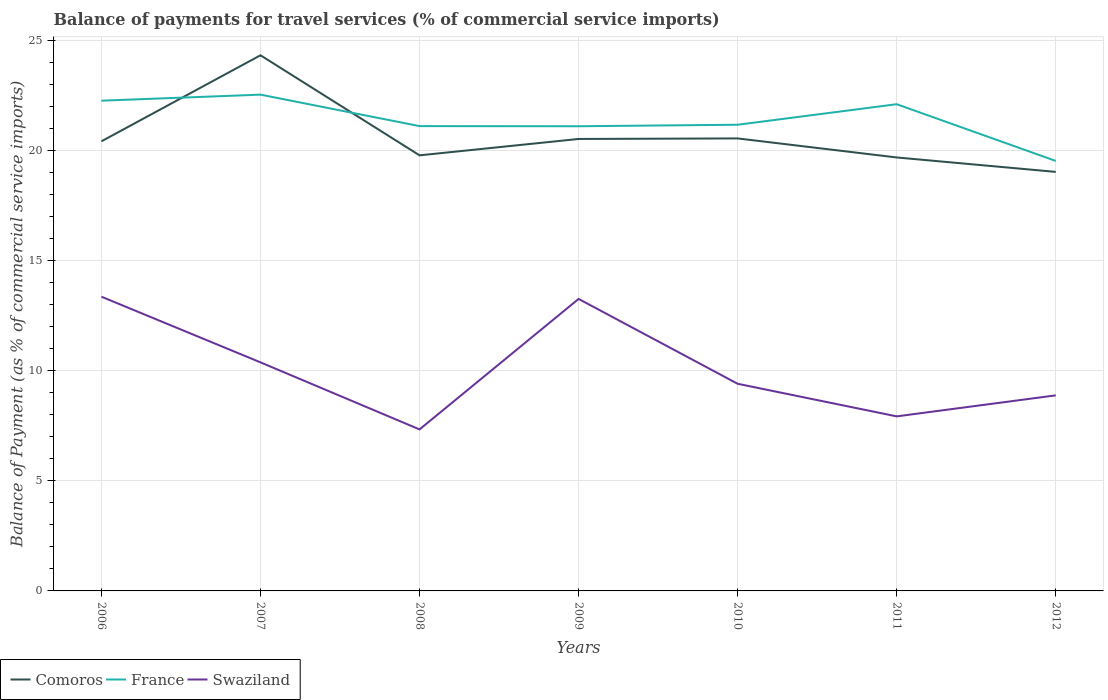Is the number of lines equal to the number of legend labels?
Keep it short and to the point. Yes. Across all years, what is the maximum balance of payments for travel services in Comoros?
Make the answer very short. 19.03. What is the total balance of payments for travel services in France in the graph?
Provide a short and direct response. 1.15. What is the difference between the highest and the second highest balance of payments for travel services in Comoros?
Provide a succinct answer. 5.3. How many lines are there?
Provide a succinct answer. 3. Are the values on the major ticks of Y-axis written in scientific E-notation?
Your answer should be compact. No. Does the graph contain any zero values?
Offer a very short reply. No. Does the graph contain grids?
Your answer should be compact. Yes. How are the legend labels stacked?
Your answer should be very brief. Horizontal. What is the title of the graph?
Your answer should be very brief. Balance of payments for travel services (% of commercial service imports). What is the label or title of the Y-axis?
Your answer should be compact. Balance of Payment (as % of commercial service imports). What is the Balance of Payment (as % of commercial service imports) in Comoros in 2006?
Provide a succinct answer. 20.42. What is the Balance of Payment (as % of commercial service imports) in France in 2006?
Ensure brevity in your answer.  22.26. What is the Balance of Payment (as % of commercial service imports) in Swaziland in 2006?
Offer a very short reply. 13.36. What is the Balance of Payment (as % of commercial service imports) of Comoros in 2007?
Offer a very short reply. 24.32. What is the Balance of Payment (as % of commercial service imports) in France in 2007?
Provide a short and direct response. 22.54. What is the Balance of Payment (as % of commercial service imports) of Swaziland in 2007?
Your answer should be compact. 10.38. What is the Balance of Payment (as % of commercial service imports) of Comoros in 2008?
Your response must be concise. 19.78. What is the Balance of Payment (as % of commercial service imports) in France in 2008?
Your answer should be very brief. 21.11. What is the Balance of Payment (as % of commercial service imports) in Swaziland in 2008?
Keep it short and to the point. 7.34. What is the Balance of Payment (as % of commercial service imports) in Comoros in 2009?
Your response must be concise. 20.52. What is the Balance of Payment (as % of commercial service imports) of France in 2009?
Ensure brevity in your answer.  21.1. What is the Balance of Payment (as % of commercial service imports) in Swaziland in 2009?
Your response must be concise. 13.26. What is the Balance of Payment (as % of commercial service imports) of Comoros in 2010?
Your response must be concise. 20.55. What is the Balance of Payment (as % of commercial service imports) of France in 2010?
Keep it short and to the point. 21.17. What is the Balance of Payment (as % of commercial service imports) of Swaziland in 2010?
Provide a succinct answer. 9.41. What is the Balance of Payment (as % of commercial service imports) of Comoros in 2011?
Give a very brief answer. 19.68. What is the Balance of Payment (as % of commercial service imports) in France in 2011?
Give a very brief answer. 22.1. What is the Balance of Payment (as % of commercial service imports) in Swaziland in 2011?
Your answer should be very brief. 7.93. What is the Balance of Payment (as % of commercial service imports) of Comoros in 2012?
Provide a short and direct response. 19.03. What is the Balance of Payment (as % of commercial service imports) in France in 2012?
Ensure brevity in your answer.  19.53. What is the Balance of Payment (as % of commercial service imports) in Swaziland in 2012?
Offer a terse response. 8.88. Across all years, what is the maximum Balance of Payment (as % of commercial service imports) in Comoros?
Provide a short and direct response. 24.32. Across all years, what is the maximum Balance of Payment (as % of commercial service imports) in France?
Provide a short and direct response. 22.54. Across all years, what is the maximum Balance of Payment (as % of commercial service imports) in Swaziland?
Provide a short and direct response. 13.36. Across all years, what is the minimum Balance of Payment (as % of commercial service imports) of Comoros?
Offer a terse response. 19.03. Across all years, what is the minimum Balance of Payment (as % of commercial service imports) in France?
Your answer should be very brief. 19.53. Across all years, what is the minimum Balance of Payment (as % of commercial service imports) in Swaziland?
Your response must be concise. 7.34. What is the total Balance of Payment (as % of commercial service imports) of Comoros in the graph?
Offer a terse response. 144.31. What is the total Balance of Payment (as % of commercial service imports) of France in the graph?
Make the answer very short. 149.81. What is the total Balance of Payment (as % of commercial service imports) in Swaziland in the graph?
Ensure brevity in your answer.  70.55. What is the difference between the Balance of Payment (as % of commercial service imports) in Comoros in 2006 and that in 2007?
Give a very brief answer. -3.91. What is the difference between the Balance of Payment (as % of commercial service imports) of France in 2006 and that in 2007?
Offer a very short reply. -0.27. What is the difference between the Balance of Payment (as % of commercial service imports) in Swaziland in 2006 and that in 2007?
Give a very brief answer. 2.98. What is the difference between the Balance of Payment (as % of commercial service imports) in Comoros in 2006 and that in 2008?
Keep it short and to the point. 0.64. What is the difference between the Balance of Payment (as % of commercial service imports) of France in 2006 and that in 2008?
Give a very brief answer. 1.15. What is the difference between the Balance of Payment (as % of commercial service imports) in Swaziland in 2006 and that in 2008?
Provide a succinct answer. 6.03. What is the difference between the Balance of Payment (as % of commercial service imports) of Comoros in 2006 and that in 2009?
Your response must be concise. -0.11. What is the difference between the Balance of Payment (as % of commercial service imports) of France in 2006 and that in 2009?
Offer a terse response. 1.16. What is the difference between the Balance of Payment (as % of commercial service imports) of Swaziland in 2006 and that in 2009?
Offer a very short reply. 0.1. What is the difference between the Balance of Payment (as % of commercial service imports) of Comoros in 2006 and that in 2010?
Your answer should be very brief. -0.13. What is the difference between the Balance of Payment (as % of commercial service imports) in France in 2006 and that in 2010?
Ensure brevity in your answer.  1.09. What is the difference between the Balance of Payment (as % of commercial service imports) in Swaziland in 2006 and that in 2010?
Provide a short and direct response. 3.95. What is the difference between the Balance of Payment (as % of commercial service imports) of Comoros in 2006 and that in 2011?
Your answer should be compact. 0.73. What is the difference between the Balance of Payment (as % of commercial service imports) of France in 2006 and that in 2011?
Your answer should be compact. 0.16. What is the difference between the Balance of Payment (as % of commercial service imports) in Swaziland in 2006 and that in 2011?
Keep it short and to the point. 5.43. What is the difference between the Balance of Payment (as % of commercial service imports) in Comoros in 2006 and that in 2012?
Make the answer very short. 1.39. What is the difference between the Balance of Payment (as % of commercial service imports) of France in 2006 and that in 2012?
Your answer should be compact. 2.74. What is the difference between the Balance of Payment (as % of commercial service imports) of Swaziland in 2006 and that in 2012?
Your answer should be very brief. 4.48. What is the difference between the Balance of Payment (as % of commercial service imports) in Comoros in 2007 and that in 2008?
Ensure brevity in your answer.  4.54. What is the difference between the Balance of Payment (as % of commercial service imports) in France in 2007 and that in 2008?
Your answer should be very brief. 1.43. What is the difference between the Balance of Payment (as % of commercial service imports) in Swaziland in 2007 and that in 2008?
Offer a very short reply. 3.04. What is the difference between the Balance of Payment (as % of commercial service imports) in Comoros in 2007 and that in 2009?
Your response must be concise. 3.8. What is the difference between the Balance of Payment (as % of commercial service imports) in France in 2007 and that in 2009?
Offer a very short reply. 1.44. What is the difference between the Balance of Payment (as % of commercial service imports) of Swaziland in 2007 and that in 2009?
Your answer should be compact. -2.88. What is the difference between the Balance of Payment (as % of commercial service imports) of Comoros in 2007 and that in 2010?
Give a very brief answer. 3.78. What is the difference between the Balance of Payment (as % of commercial service imports) of France in 2007 and that in 2010?
Offer a very short reply. 1.37. What is the difference between the Balance of Payment (as % of commercial service imports) of Swaziland in 2007 and that in 2010?
Offer a terse response. 0.97. What is the difference between the Balance of Payment (as % of commercial service imports) of Comoros in 2007 and that in 2011?
Make the answer very short. 4.64. What is the difference between the Balance of Payment (as % of commercial service imports) of France in 2007 and that in 2011?
Keep it short and to the point. 0.43. What is the difference between the Balance of Payment (as % of commercial service imports) of Swaziland in 2007 and that in 2011?
Offer a terse response. 2.45. What is the difference between the Balance of Payment (as % of commercial service imports) of Comoros in 2007 and that in 2012?
Your answer should be compact. 5.3. What is the difference between the Balance of Payment (as % of commercial service imports) in France in 2007 and that in 2012?
Make the answer very short. 3.01. What is the difference between the Balance of Payment (as % of commercial service imports) in Swaziland in 2007 and that in 2012?
Ensure brevity in your answer.  1.5. What is the difference between the Balance of Payment (as % of commercial service imports) in Comoros in 2008 and that in 2009?
Make the answer very short. -0.74. What is the difference between the Balance of Payment (as % of commercial service imports) of France in 2008 and that in 2009?
Provide a short and direct response. 0.01. What is the difference between the Balance of Payment (as % of commercial service imports) in Swaziland in 2008 and that in 2009?
Keep it short and to the point. -5.92. What is the difference between the Balance of Payment (as % of commercial service imports) in Comoros in 2008 and that in 2010?
Your response must be concise. -0.77. What is the difference between the Balance of Payment (as % of commercial service imports) in France in 2008 and that in 2010?
Give a very brief answer. -0.06. What is the difference between the Balance of Payment (as % of commercial service imports) in Swaziland in 2008 and that in 2010?
Your response must be concise. -2.07. What is the difference between the Balance of Payment (as % of commercial service imports) of Comoros in 2008 and that in 2011?
Keep it short and to the point. 0.1. What is the difference between the Balance of Payment (as % of commercial service imports) in France in 2008 and that in 2011?
Offer a very short reply. -0.99. What is the difference between the Balance of Payment (as % of commercial service imports) in Swaziland in 2008 and that in 2011?
Ensure brevity in your answer.  -0.59. What is the difference between the Balance of Payment (as % of commercial service imports) of Comoros in 2008 and that in 2012?
Your answer should be compact. 0.75. What is the difference between the Balance of Payment (as % of commercial service imports) of France in 2008 and that in 2012?
Ensure brevity in your answer.  1.58. What is the difference between the Balance of Payment (as % of commercial service imports) in Swaziland in 2008 and that in 2012?
Keep it short and to the point. -1.55. What is the difference between the Balance of Payment (as % of commercial service imports) in Comoros in 2009 and that in 2010?
Keep it short and to the point. -0.02. What is the difference between the Balance of Payment (as % of commercial service imports) of France in 2009 and that in 2010?
Provide a short and direct response. -0.07. What is the difference between the Balance of Payment (as % of commercial service imports) of Swaziland in 2009 and that in 2010?
Offer a terse response. 3.85. What is the difference between the Balance of Payment (as % of commercial service imports) in Comoros in 2009 and that in 2011?
Your answer should be compact. 0.84. What is the difference between the Balance of Payment (as % of commercial service imports) in France in 2009 and that in 2011?
Ensure brevity in your answer.  -1. What is the difference between the Balance of Payment (as % of commercial service imports) of Swaziland in 2009 and that in 2011?
Your answer should be compact. 5.33. What is the difference between the Balance of Payment (as % of commercial service imports) in Comoros in 2009 and that in 2012?
Provide a short and direct response. 1.5. What is the difference between the Balance of Payment (as % of commercial service imports) in France in 2009 and that in 2012?
Provide a short and direct response. 1.58. What is the difference between the Balance of Payment (as % of commercial service imports) in Swaziland in 2009 and that in 2012?
Provide a short and direct response. 4.38. What is the difference between the Balance of Payment (as % of commercial service imports) in Comoros in 2010 and that in 2011?
Keep it short and to the point. 0.86. What is the difference between the Balance of Payment (as % of commercial service imports) of France in 2010 and that in 2011?
Keep it short and to the point. -0.93. What is the difference between the Balance of Payment (as % of commercial service imports) of Swaziland in 2010 and that in 2011?
Give a very brief answer. 1.48. What is the difference between the Balance of Payment (as % of commercial service imports) of Comoros in 2010 and that in 2012?
Your response must be concise. 1.52. What is the difference between the Balance of Payment (as % of commercial service imports) in France in 2010 and that in 2012?
Your answer should be compact. 1.64. What is the difference between the Balance of Payment (as % of commercial service imports) of Swaziland in 2010 and that in 2012?
Offer a terse response. 0.53. What is the difference between the Balance of Payment (as % of commercial service imports) in Comoros in 2011 and that in 2012?
Your response must be concise. 0.66. What is the difference between the Balance of Payment (as % of commercial service imports) of France in 2011 and that in 2012?
Your answer should be compact. 2.58. What is the difference between the Balance of Payment (as % of commercial service imports) in Swaziland in 2011 and that in 2012?
Your answer should be very brief. -0.95. What is the difference between the Balance of Payment (as % of commercial service imports) in Comoros in 2006 and the Balance of Payment (as % of commercial service imports) in France in 2007?
Keep it short and to the point. -2.12. What is the difference between the Balance of Payment (as % of commercial service imports) in Comoros in 2006 and the Balance of Payment (as % of commercial service imports) in Swaziland in 2007?
Keep it short and to the point. 10.04. What is the difference between the Balance of Payment (as % of commercial service imports) in France in 2006 and the Balance of Payment (as % of commercial service imports) in Swaziland in 2007?
Your answer should be compact. 11.88. What is the difference between the Balance of Payment (as % of commercial service imports) of Comoros in 2006 and the Balance of Payment (as % of commercial service imports) of France in 2008?
Keep it short and to the point. -0.69. What is the difference between the Balance of Payment (as % of commercial service imports) in Comoros in 2006 and the Balance of Payment (as % of commercial service imports) in Swaziland in 2008?
Provide a short and direct response. 13.08. What is the difference between the Balance of Payment (as % of commercial service imports) of France in 2006 and the Balance of Payment (as % of commercial service imports) of Swaziland in 2008?
Offer a very short reply. 14.93. What is the difference between the Balance of Payment (as % of commercial service imports) of Comoros in 2006 and the Balance of Payment (as % of commercial service imports) of France in 2009?
Your answer should be compact. -0.68. What is the difference between the Balance of Payment (as % of commercial service imports) of Comoros in 2006 and the Balance of Payment (as % of commercial service imports) of Swaziland in 2009?
Your answer should be compact. 7.16. What is the difference between the Balance of Payment (as % of commercial service imports) of France in 2006 and the Balance of Payment (as % of commercial service imports) of Swaziland in 2009?
Make the answer very short. 9. What is the difference between the Balance of Payment (as % of commercial service imports) of Comoros in 2006 and the Balance of Payment (as % of commercial service imports) of France in 2010?
Your answer should be compact. -0.75. What is the difference between the Balance of Payment (as % of commercial service imports) in Comoros in 2006 and the Balance of Payment (as % of commercial service imports) in Swaziland in 2010?
Provide a short and direct response. 11.01. What is the difference between the Balance of Payment (as % of commercial service imports) in France in 2006 and the Balance of Payment (as % of commercial service imports) in Swaziland in 2010?
Your answer should be very brief. 12.86. What is the difference between the Balance of Payment (as % of commercial service imports) of Comoros in 2006 and the Balance of Payment (as % of commercial service imports) of France in 2011?
Make the answer very short. -1.68. What is the difference between the Balance of Payment (as % of commercial service imports) in Comoros in 2006 and the Balance of Payment (as % of commercial service imports) in Swaziland in 2011?
Make the answer very short. 12.49. What is the difference between the Balance of Payment (as % of commercial service imports) of France in 2006 and the Balance of Payment (as % of commercial service imports) of Swaziland in 2011?
Keep it short and to the point. 14.34. What is the difference between the Balance of Payment (as % of commercial service imports) in Comoros in 2006 and the Balance of Payment (as % of commercial service imports) in France in 2012?
Your answer should be compact. 0.89. What is the difference between the Balance of Payment (as % of commercial service imports) in Comoros in 2006 and the Balance of Payment (as % of commercial service imports) in Swaziland in 2012?
Your answer should be compact. 11.54. What is the difference between the Balance of Payment (as % of commercial service imports) in France in 2006 and the Balance of Payment (as % of commercial service imports) in Swaziland in 2012?
Make the answer very short. 13.38. What is the difference between the Balance of Payment (as % of commercial service imports) in Comoros in 2007 and the Balance of Payment (as % of commercial service imports) in France in 2008?
Ensure brevity in your answer.  3.22. What is the difference between the Balance of Payment (as % of commercial service imports) of Comoros in 2007 and the Balance of Payment (as % of commercial service imports) of Swaziland in 2008?
Your answer should be very brief. 16.99. What is the difference between the Balance of Payment (as % of commercial service imports) in France in 2007 and the Balance of Payment (as % of commercial service imports) in Swaziland in 2008?
Give a very brief answer. 15.2. What is the difference between the Balance of Payment (as % of commercial service imports) of Comoros in 2007 and the Balance of Payment (as % of commercial service imports) of France in 2009?
Provide a short and direct response. 3.22. What is the difference between the Balance of Payment (as % of commercial service imports) of Comoros in 2007 and the Balance of Payment (as % of commercial service imports) of Swaziland in 2009?
Ensure brevity in your answer.  11.06. What is the difference between the Balance of Payment (as % of commercial service imports) in France in 2007 and the Balance of Payment (as % of commercial service imports) in Swaziland in 2009?
Offer a terse response. 9.28. What is the difference between the Balance of Payment (as % of commercial service imports) of Comoros in 2007 and the Balance of Payment (as % of commercial service imports) of France in 2010?
Give a very brief answer. 3.15. What is the difference between the Balance of Payment (as % of commercial service imports) in Comoros in 2007 and the Balance of Payment (as % of commercial service imports) in Swaziland in 2010?
Offer a terse response. 14.92. What is the difference between the Balance of Payment (as % of commercial service imports) in France in 2007 and the Balance of Payment (as % of commercial service imports) in Swaziland in 2010?
Make the answer very short. 13.13. What is the difference between the Balance of Payment (as % of commercial service imports) in Comoros in 2007 and the Balance of Payment (as % of commercial service imports) in France in 2011?
Make the answer very short. 2.22. What is the difference between the Balance of Payment (as % of commercial service imports) in Comoros in 2007 and the Balance of Payment (as % of commercial service imports) in Swaziland in 2011?
Offer a very short reply. 16.4. What is the difference between the Balance of Payment (as % of commercial service imports) of France in 2007 and the Balance of Payment (as % of commercial service imports) of Swaziland in 2011?
Ensure brevity in your answer.  14.61. What is the difference between the Balance of Payment (as % of commercial service imports) in Comoros in 2007 and the Balance of Payment (as % of commercial service imports) in France in 2012?
Your answer should be compact. 4.8. What is the difference between the Balance of Payment (as % of commercial service imports) of Comoros in 2007 and the Balance of Payment (as % of commercial service imports) of Swaziland in 2012?
Offer a very short reply. 15.44. What is the difference between the Balance of Payment (as % of commercial service imports) of France in 2007 and the Balance of Payment (as % of commercial service imports) of Swaziland in 2012?
Ensure brevity in your answer.  13.66. What is the difference between the Balance of Payment (as % of commercial service imports) of Comoros in 2008 and the Balance of Payment (as % of commercial service imports) of France in 2009?
Your response must be concise. -1.32. What is the difference between the Balance of Payment (as % of commercial service imports) in Comoros in 2008 and the Balance of Payment (as % of commercial service imports) in Swaziland in 2009?
Ensure brevity in your answer.  6.52. What is the difference between the Balance of Payment (as % of commercial service imports) of France in 2008 and the Balance of Payment (as % of commercial service imports) of Swaziland in 2009?
Provide a succinct answer. 7.85. What is the difference between the Balance of Payment (as % of commercial service imports) in Comoros in 2008 and the Balance of Payment (as % of commercial service imports) in France in 2010?
Offer a very short reply. -1.39. What is the difference between the Balance of Payment (as % of commercial service imports) in Comoros in 2008 and the Balance of Payment (as % of commercial service imports) in Swaziland in 2010?
Give a very brief answer. 10.37. What is the difference between the Balance of Payment (as % of commercial service imports) of France in 2008 and the Balance of Payment (as % of commercial service imports) of Swaziland in 2010?
Give a very brief answer. 11.7. What is the difference between the Balance of Payment (as % of commercial service imports) of Comoros in 2008 and the Balance of Payment (as % of commercial service imports) of France in 2011?
Make the answer very short. -2.32. What is the difference between the Balance of Payment (as % of commercial service imports) of Comoros in 2008 and the Balance of Payment (as % of commercial service imports) of Swaziland in 2011?
Give a very brief answer. 11.85. What is the difference between the Balance of Payment (as % of commercial service imports) in France in 2008 and the Balance of Payment (as % of commercial service imports) in Swaziland in 2011?
Ensure brevity in your answer.  13.18. What is the difference between the Balance of Payment (as % of commercial service imports) of Comoros in 2008 and the Balance of Payment (as % of commercial service imports) of France in 2012?
Give a very brief answer. 0.25. What is the difference between the Balance of Payment (as % of commercial service imports) of Comoros in 2008 and the Balance of Payment (as % of commercial service imports) of Swaziland in 2012?
Provide a succinct answer. 10.9. What is the difference between the Balance of Payment (as % of commercial service imports) of France in 2008 and the Balance of Payment (as % of commercial service imports) of Swaziland in 2012?
Give a very brief answer. 12.23. What is the difference between the Balance of Payment (as % of commercial service imports) of Comoros in 2009 and the Balance of Payment (as % of commercial service imports) of France in 2010?
Make the answer very short. -0.65. What is the difference between the Balance of Payment (as % of commercial service imports) in Comoros in 2009 and the Balance of Payment (as % of commercial service imports) in Swaziland in 2010?
Provide a succinct answer. 11.12. What is the difference between the Balance of Payment (as % of commercial service imports) in France in 2009 and the Balance of Payment (as % of commercial service imports) in Swaziland in 2010?
Provide a short and direct response. 11.69. What is the difference between the Balance of Payment (as % of commercial service imports) in Comoros in 2009 and the Balance of Payment (as % of commercial service imports) in France in 2011?
Offer a very short reply. -1.58. What is the difference between the Balance of Payment (as % of commercial service imports) of Comoros in 2009 and the Balance of Payment (as % of commercial service imports) of Swaziland in 2011?
Provide a short and direct response. 12.6. What is the difference between the Balance of Payment (as % of commercial service imports) of France in 2009 and the Balance of Payment (as % of commercial service imports) of Swaziland in 2011?
Provide a short and direct response. 13.17. What is the difference between the Balance of Payment (as % of commercial service imports) in Comoros in 2009 and the Balance of Payment (as % of commercial service imports) in Swaziland in 2012?
Your response must be concise. 11.64. What is the difference between the Balance of Payment (as % of commercial service imports) of France in 2009 and the Balance of Payment (as % of commercial service imports) of Swaziland in 2012?
Your answer should be compact. 12.22. What is the difference between the Balance of Payment (as % of commercial service imports) of Comoros in 2010 and the Balance of Payment (as % of commercial service imports) of France in 2011?
Give a very brief answer. -1.55. What is the difference between the Balance of Payment (as % of commercial service imports) in Comoros in 2010 and the Balance of Payment (as % of commercial service imports) in Swaziland in 2011?
Make the answer very short. 12.62. What is the difference between the Balance of Payment (as % of commercial service imports) in France in 2010 and the Balance of Payment (as % of commercial service imports) in Swaziland in 2011?
Keep it short and to the point. 13.24. What is the difference between the Balance of Payment (as % of commercial service imports) of Comoros in 2010 and the Balance of Payment (as % of commercial service imports) of France in 2012?
Your answer should be very brief. 1.02. What is the difference between the Balance of Payment (as % of commercial service imports) of Comoros in 2010 and the Balance of Payment (as % of commercial service imports) of Swaziland in 2012?
Your answer should be very brief. 11.67. What is the difference between the Balance of Payment (as % of commercial service imports) of France in 2010 and the Balance of Payment (as % of commercial service imports) of Swaziland in 2012?
Provide a succinct answer. 12.29. What is the difference between the Balance of Payment (as % of commercial service imports) in Comoros in 2011 and the Balance of Payment (as % of commercial service imports) in France in 2012?
Give a very brief answer. 0.16. What is the difference between the Balance of Payment (as % of commercial service imports) of Comoros in 2011 and the Balance of Payment (as % of commercial service imports) of Swaziland in 2012?
Offer a very short reply. 10.8. What is the difference between the Balance of Payment (as % of commercial service imports) in France in 2011 and the Balance of Payment (as % of commercial service imports) in Swaziland in 2012?
Offer a terse response. 13.22. What is the average Balance of Payment (as % of commercial service imports) in Comoros per year?
Provide a short and direct response. 20.62. What is the average Balance of Payment (as % of commercial service imports) in France per year?
Provide a short and direct response. 21.4. What is the average Balance of Payment (as % of commercial service imports) in Swaziland per year?
Ensure brevity in your answer.  10.08. In the year 2006, what is the difference between the Balance of Payment (as % of commercial service imports) of Comoros and Balance of Payment (as % of commercial service imports) of France?
Give a very brief answer. -1.84. In the year 2006, what is the difference between the Balance of Payment (as % of commercial service imports) in Comoros and Balance of Payment (as % of commercial service imports) in Swaziland?
Ensure brevity in your answer.  7.06. In the year 2006, what is the difference between the Balance of Payment (as % of commercial service imports) of France and Balance of Payment (as % of commercial service imports) of Swaziland?
Your response must be concise. 8.9. In the year 2007, what is the difference between the Balance of Payment (as % of commercial service imports) in Comoros and Balance of Payment (as % of commercial service imports) in France?
Your answer should be very brief. 1.79. In the year 2007, what is the difference between the Balance of Payment (as % of commercial service imports) in Comoros and Balance of Payment (as % of commercial service imports) in Swaziland?
Offer a terse response. 13.94. In the year 2007, what is the difference between the Balance of Payment (as % of commercial service imports) of France and Balance of Payment (as % of commercial service imports) of Swaziland?
Give a very brief answer. 12.16. In the year 2008, what is the difference between the Balance of Payment (as % of commercial service imports) in Comoros and Balance of Payment (as % of commercial service imports) in France?
Your response must be concise. -1.33. In the year 2008, what is the difference between the Balance of Payment (as % of commercial service imports) of Comoros and Balance of Payment (as % of commercial service imports) of Swaziland?
Give a very brief answer. 12.45. In the year 2008, what is the difference between the Balance of Payment (as % of commercial service imports) in France and Balance of Payment (as % of commercial service imports) in Swaziland?
Offer a very short reply. 13.77. In the year 2009, what is the difference between the Balance of Payment (as % of commercial service imports) in Comoros and Balance of Payment (as % of commercial service imports) in France?
Keep it short and to the point. -0.58. In the year 2009, what is the difference between the Balance of Payment (as % of commercial service imports) in Comoros and Balance of Payment (as % of commercial service imports) in Swaziland?
Offer a terse response. 7.26. In the year 2009, what is the difference between the Balance of Payment (as % of commercial service imports) of France and Balance of Payment (as % of commercial service imports) of Swaziland?
Provide a succinct answer. 7.84. In the year 2010, what is the difference between the Balance of Payment (as % of commercial service imports) of Comoros and Balance of Payment (as % of commercial service imports) of France?
Your response must be concise. -0.62. In the year 2010, what is the difference between the Balance of Payment (as % of commercial service imports) in Comoros and Balance of Payment (as % of commercial service imports) in Swaziland?
Give a very brief answer. 11.14. In the year 2010, what is the difference between the Balance of Payment (as % of commercial service imports) in France and Balance of Payment (as % of commercial service imports) in Swaziland?
Make the answer very short. 11.76. In the year 2011, what is the difference between the Balance of Payment (as % of commercial service imports) of Comoros and Balance of Payment (as % of commercial service imports) of France?
Offer a terse response. -2.42. In the year 2011, what is the difference between the Balance of Payment (as % of commercial service imports) of Comoros and Balance of Payment (as % of commercial service imports) of Swaziland?
Provide a succinct answer. 11.76. In the year 2011, what is the difference between the Balance of Payment (as % of commercial service imports) in France and Balance of Payment (as % of commercial service imports) in Swaziland?
Provide a succinct answer. 14.18. In the year 2012, what is the difference between the Balance of Payment (as % of commercial service imports) in Comoros and Balance of Payment (as % of commercial service imports) in France?
Offer a terse response. -0.5. In the year 2012, what is the difference between the Balance of Payment (as % of commercial service imports) of Comoros and Balance of Payment (as % of commercial service imports) of Swaziland?
Your answer should be very brief. 10.15. In the year 2012, what is the difference between the Balance of Payment (as % of commercial service imports) of France and Balance of Payment (as % of commercial service imports) of Swaziland?
Your answer should be very brief. 10.65. What is the ratio of the Balance of Payment (as % of commercial service imports) of Comoros in 2006 to that in 2007?
Provide a short and direct response. 0.84. What is the ratio of the Balance of Payment (as % of commercial service imports) of France in 2006 to that in 2007?
Give a very brief answer. 0.99. What is the ratio of the Balance of Payment (as % of commercial service imports) in Swaziland in 2006 to that in 2007?
Your answer should be very brief. 1.29. What is the ratio of the Balance of Payment (as % of commercial service imports) in Comoros in 2006 to that in 2008?
Make the answer very short. 1.03. What is the ratio of the Balance of Payment (as % of commercial service imports) of France in 2006 to that in 2008?
Offer a terse response. 1.05. What is the ratio of the Balance of Payment (as % of commercial service imports) of Swaziland in 2006 to that in 2008?
Provide a succinct answer. 1.82. What is the ratio of the Balance of Payment (as % of commercial service imports) of Comoros in 2006 to that in 2009?
Keep it short and to the point. 0.99. What is the ratio of the Balance of Payment (as % of commercial service imports) in France in 2006 to that in 2009?
Your response must be concise. 1.05. What is the ratio of the Balance of Payment (as % of commercial service imports) of Swaziland in 2006 to that in 2009?
Ensure brevity in your answer.  1.01. What is the ratio of the Balance of Payment (as % of commercial service imports) of Comoros in 2006 to that in 2010?
Make the answer very short. 0.99. What is the ratio of the Balance of Payment (as % of commercial service imports) of France in 2006 to that in 2010?
Your answer should be compact. 1.05. What is the ratio of the Balance of Payment (as % of commercial service imports) in Swaziland in 2006 to that in 2010?
Ensure brevity in your answer.  1.42. What is the ratio of the Balance of Payment (as % of commercial service imports) of Comoros in 2006 to that in 2011?
Offer a terse response. 1.04. What is the ratio of the Balance of Payment (as % of commercial service imports) of France in 2006 to that in 2011?
Your answer should be very brief. 1.01. What is the ratio of the Balance of Payment (as % of commercial service imports) of Swaziland in 2006 to that in 2011?
Ensure brevity in your answer.  1.69. What is the ratio of the Balance of Payment (as % of commercial service imports) in Comoros in 2006 to that in 2012?
Your response must be concise. 1.07. What is the ratio of the Balance of Payment (as % of commercial service imports) in France in 2006 to that in 2012?
Your answer should be very brief. 1.14. What is the ratio of the Balance of Payment (as % of commercial service imports) of Swaziland in 2006 to that in 2012?
Make the answer very short. 1.5. What is the ratio of the Balance of Payment (as % of commercial service imports) of Comoros in 2007 to that in 2008?
Give a very brief answer. 1.23. What is the ratio of the Balance of Payment (as % of commercial service imports) of France in 2007 to that in 2008?
Make the answer very short. 1.07. What is the ratio of the Balance of Payment (as % of commercial service imports) in Swaziland in 2007 to that in 2008?
Keep it short and to the point. 1.42. What is the ratio of the Balance of Payment (as % of commercial service imports) in Comoros in 2007 to that in 2009?
Offer a very short reply. 1.19. What is the ratio of the Balance of Payment (as % of commercial service imports) of France in 2007 to that in 2009?
Offer a terse response. 1.07. What is the ratio of the Balance of Payment (as % of commercial service imports) in Swaziland in 2007 to that in 2009?
Make the answer very short. 0.78. What is the ratio of the Balance of Payment (as % of commercial service imports) of Comoros in 2007 to that in 2010?
Offer a very short reply. 1.18. What is the ratio of the Balance of Payment (as % of commercial service imports) of France in 2007 to that in 2010?
Offer a very short reply. 1.06. What is the ratio of the Balance of Payment (as % of commercial service imports) in Swaziland in 2007 to that in 2010?
Your answer should be very brief. 1.1. What is the ratio of the Balance of Payment (as % of commercial service imports) in Comoros in 2007 to that in 2011?
Provide a short and direct response. 1.24. What is the ratio of the Balance of Payment (as % of commercial service imports) of France in 2007 to that in 2011?
Make the answer very short. 1.02. What is the ratio of the Balance of Payment (as % of commercial service imports) in Swaziland in 2007 to that in 2011?
Offer a terse response. 1.31. What is the ratio of the Balance of Payment (as % of commercial service imports) in Comoros in 2007 to that in 2012?
Make the answer very short. 1.28. What is the ratio of the Balance of Payment (as % of commercial service imports) in France in 2007 to that in 2012?
Offer a terse response. 1.15. What is the ratio of the Balance of Payment (as % of commercial service imports) in Swaziland in 2007 to that in 2012?
Offer a terse response. 1.17. What is the ratio of the Balance of Payment (as % of commercial service imports) in Comoros in 2008 to that in 2009?
Make the answer very short. 0.96. What is the ratio of the Balance of Payment (as % of commercial service imports) of France in 2008 to that in 2009?
Make the answer very short. 1. What is the ratio of the Balance of Payment (as % of commercial service imports) in Swaziland in 2008 to that in 2009?
Offer a very short reply. 0.55. What is the ratio of the Balance of Payment (as % of commercial service imports) in Comoros in 2008 to that in 2010?
Offer a very short reply. 0.96. What is the ratio of the Balance of Payment (as % of commercial service imports) of France in 2008 to that in 2010?
Provide a succinct answer. 1. What is the ratio of the Balance of Payment (as % of commercial service imports) of Swaziland in 2008 to that in 2010?
Your answer should be very brief. 0.78. What is the ratio of the Balance of Payment (as % of commercial service imports) of Comoros in 2008 to that in 2011?
Your response must be concise. 1. What is the ratio of the Balance of Payment (as % of commercial service imports) of France in 2008 to that in 2011?
Offer a terse response. 0.95. What is the ratio of the Balance of Payment (as % of commercial service imports) of Swaziland in 2008 to that in 2011?
Give a very brief answer. 0.93. What is the ratio of the Balance of Payment (as % of commercial service imports) in Comoros in 2008 to that in 2012?
Provide a succinct answer. 1.04. What is the ratio of the Balance of Payment (as % of commercial service imports) in France in 2008 to that in 2012?
Provide a succinct answer. 1.08. What is the ratio of the Balance of Payment (as % of commercial service imports) of Swaziland in 2008 to that in 2012?
Give a very brief answer. 0.83. What is the ratio of the Balance of Payment (as % of commercial service imports) of Swaziland in 2009 to that in 2010?
Ensure brevity in your answer.  1.41. What is the ratio of the Balance of Payment (as % of commercial service imports) of Comoros in 2009 to that in 2011?
Your response must be concise. 1.04. What is the ratio of the Balance of Payment (as % of commercial service imports) of France in 2009 to that in 2011?
Ensure brevity in your answer.  0.95. What is the ratio of the Balance of Payment (as % of commercial service imports) of Swaziland in 2009 to that in 2011?
Offer a very short reply. 1.67. What is the ratio of the Balance of Payment (as % of commercial service imports) in Comoros in 2009 to that in 2012?
Give a very brief answer. 1.08. What is the ratio of the Balance of Payment (as % of commercial service imports) of France in 2009 to that in 2012?
Ensure brevity in your answer.  1.08. What is the ratio of the Balance of Payment (as % of commercial service imports) in Swaziland in 2009 to that in 2012?
Offer a very short reply. 1.49. What is the ratio of the Balance of Payment (as % of commercial service imports) of Comoros in 2010 to that in 2011?
Keep it short and to the point. 1.04. What is the ratio of the Balance of Payment (as % of commercial service imports) of France in 2010 to that in 2011?
Your answer should be very brief. 0.96. What is the ratio of the Balance of Payment (as % of commercial service imports) of Swaziland in 2010 to that in 2011?
Offer a very short reply. 1.19. What is the ratio of the Balance of Payment (as % of commercial service imports) of Comoros in 2010 to that in 2012?
Offer a terse response. 1.08. What is the ratio of the Balance of Payment (as % of commercial service imports) of France in 2010 to that in 2012?
Give a very brief answer. 1.08. What is the ratio of the Balance of Payment (as % of commercial service imports) in Swaziland in 2010 to that in 2012?
Your answer should be compact. 1.06. What is the ratio of the Balance of Payment (as % of commercial service imports) in Comoros in 2011 to that in 2012?
Offer a terse response. 1.03. What is the ratio of the Balance of Payment (as % of commercial service imports) in France in 2011 to that in 2012?
Give a very brief answer. 1.13. What is the ratio of the Balance of Payment (as % of commercial service imports) in Swaziland in 2011 to that in 2012?
Offer a terse response. 0.89. What is the difference between the highest and the second highest Balance of Payment (as % of commercial service imports) in Comoros?
Your answer should be compact. 3.78. What is the difference between the highest and the second highest Balance of Payment (as % of commercial service imports) of France?
Your response must be concise. 0.27. What is the difference between the highest and the second highest Balance of Payment (as % of commercial service imports) of Swaziland?
Provide a short and direct response. 0.1. What is the difference between the highest and the lowest Balance of Payment (as % of commercial service imports) in Comoros?
Provide a short and direct response. 5.3. What is the difference between the highest and the lowest Balance of Payment (as % of commercial service imports) of France?
Provide a short and direct response. 3.01. What is the difference between the highest and the lowest Balance of Payment (as % of commercial service imports) in Swaziland?
Provide a succinct answer. 6.03. 